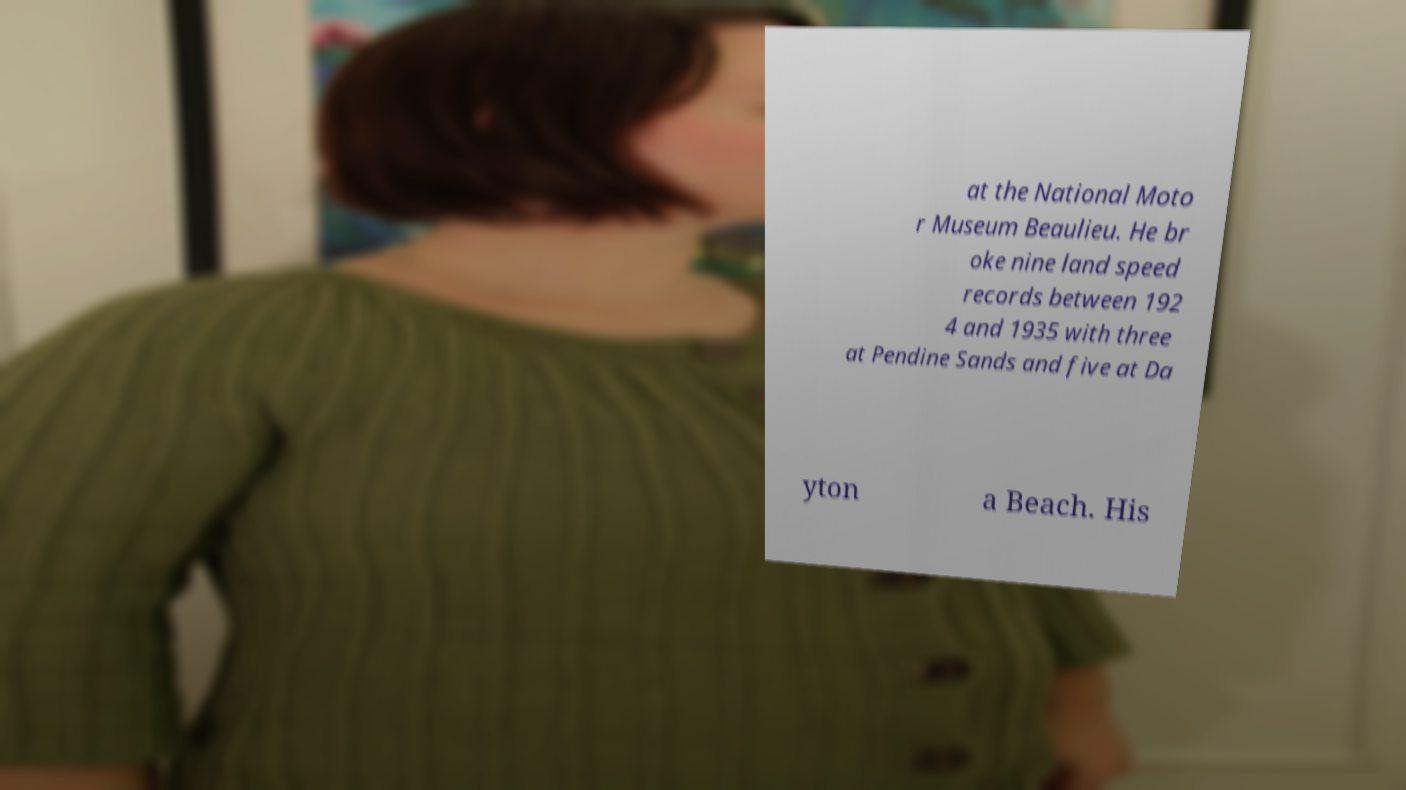Please read and relay the text visible in this image. What does it say? at the National Moto r Museum Beaulieu. He br oke nine land speed records between 192 4 and 1935 with three at Pendine Sands and five at Da yton a Beach. His 